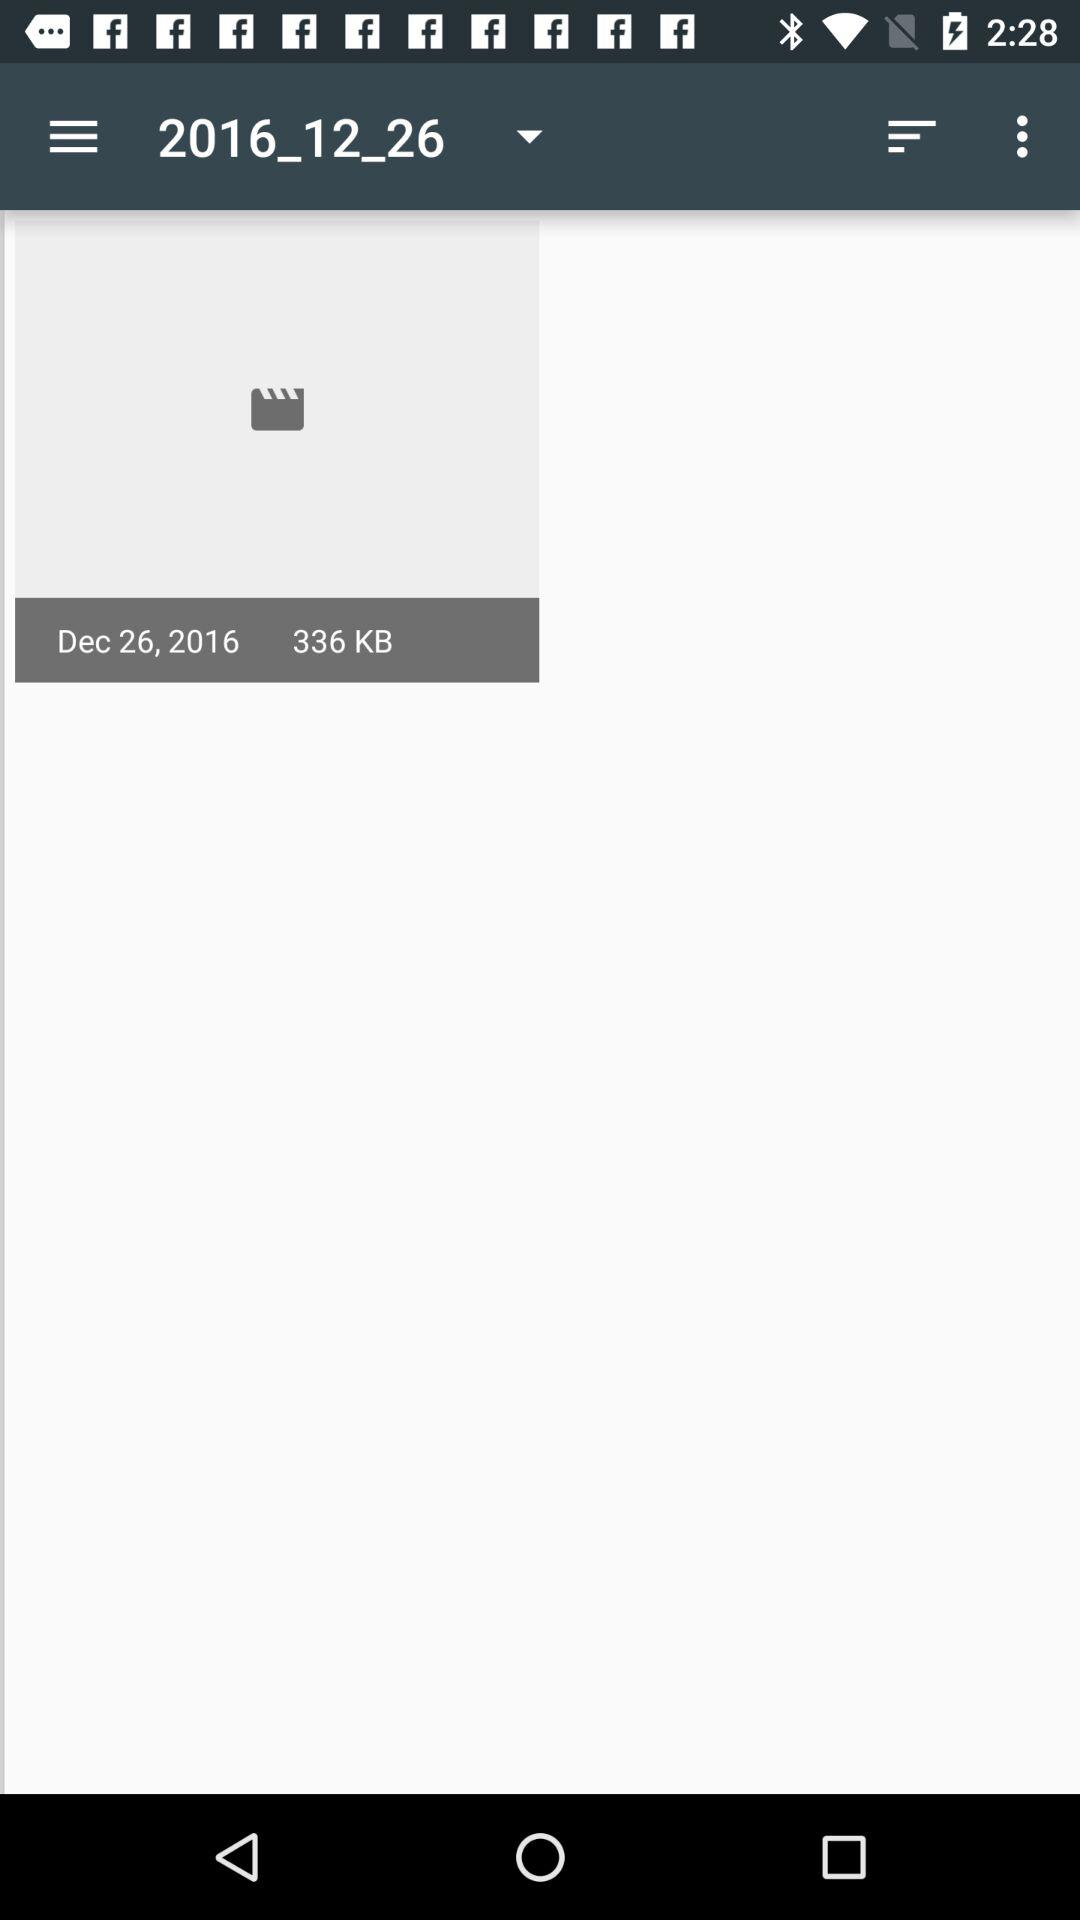What is the given date? The given date is December 26, 2016. 